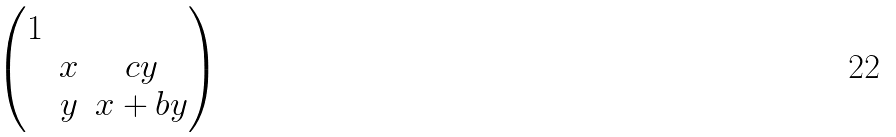Convert formula to latex. <formula><loc_0><loc_0><loc_500><loc_500>\begin{pmatrix} 1 & & \\ & x & c y \\ & y & x + b y \end{pmatrix}</formula> 